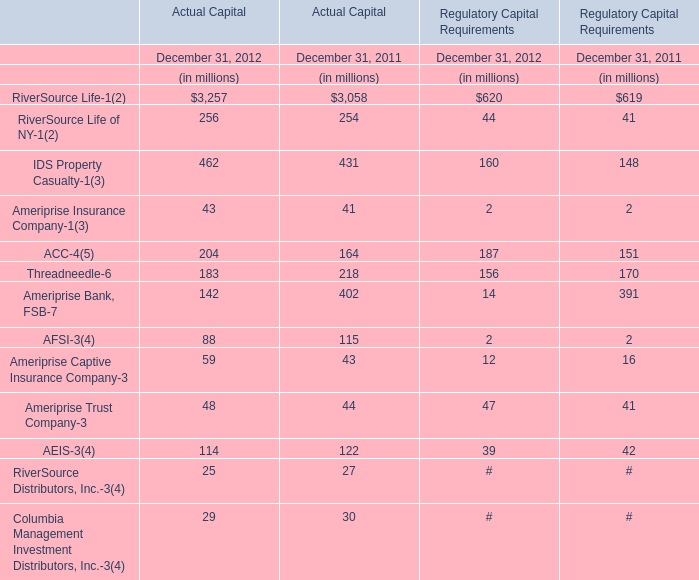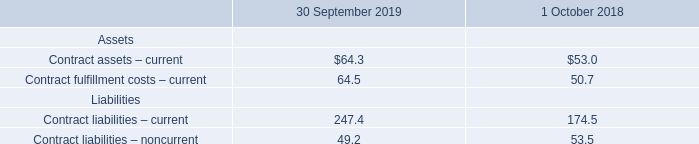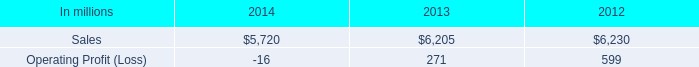How much of Actual Capital is there in total in 2012 without RiverSource Life-1 and RiverSource Life of NY-1? (in million) 
Computations: ((((((((((462 + 43) + 204) + 183) + 142) + 88) + 59) + 48) + 114) + 25) + 29)
Answer: 1397.0. 